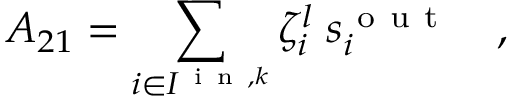<formula> <loc_0><loc_0><loc_500><loc_500>A _ { 2 1 } = \sum _ { i \in I ^ { i n , k } } \zeta _ { i } ^ { l } \, s _ { i } ^ { o u t } \quad ,</formula> 